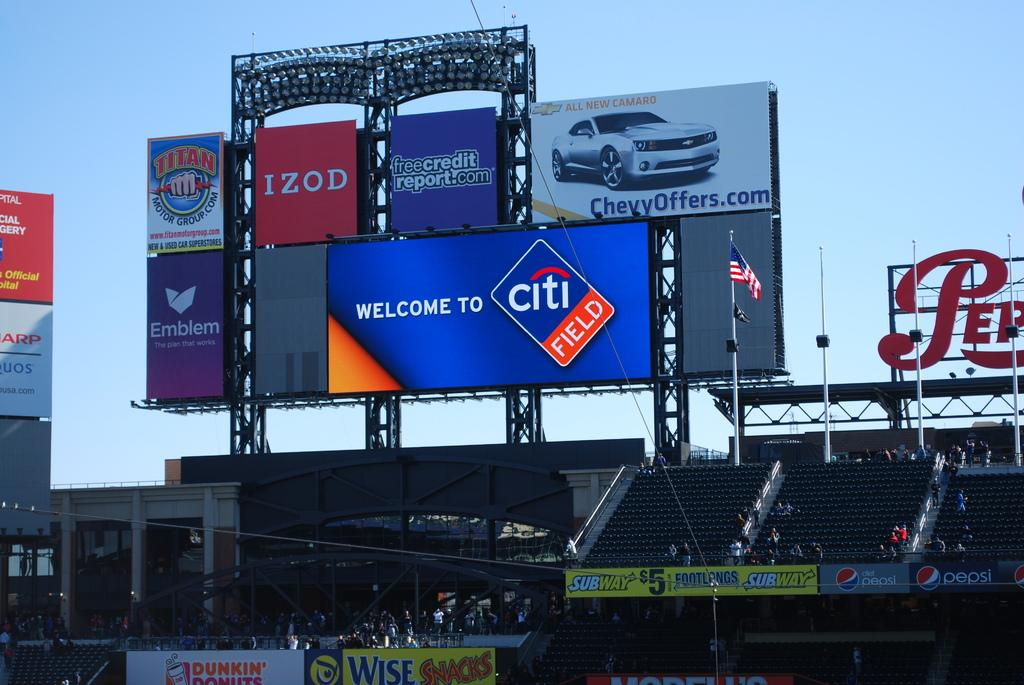Provide a one-sentence caption for the provided image. The inside of a baseball arena showing advertising for Izod and freecreditreport.com. 